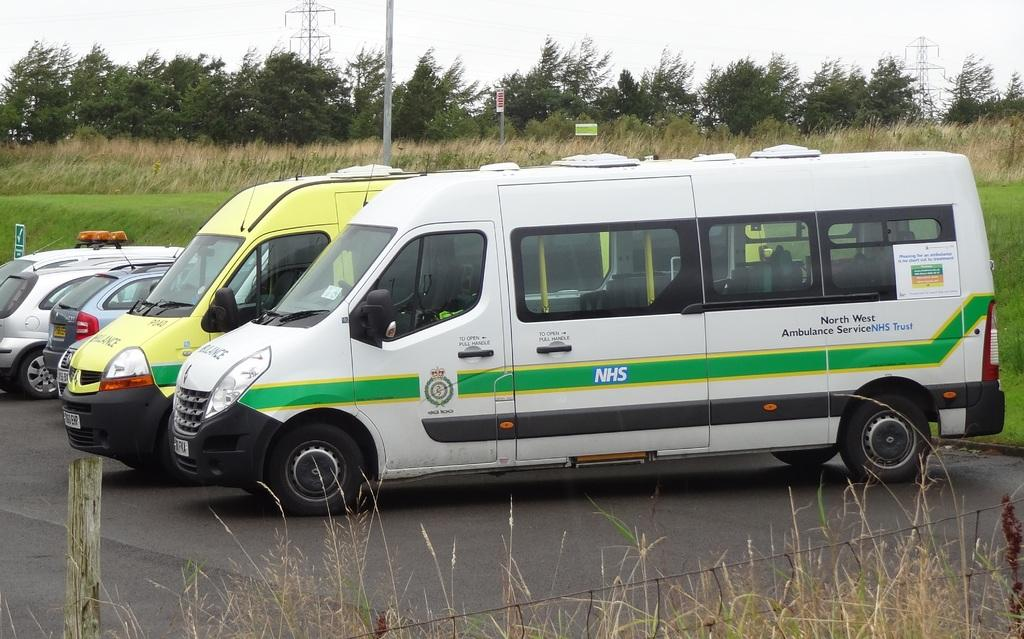Provide a one-sentence caption for the provided image. Two vans and two cars are parked, one van bearing the letters NHS in a green stripe on its side. 